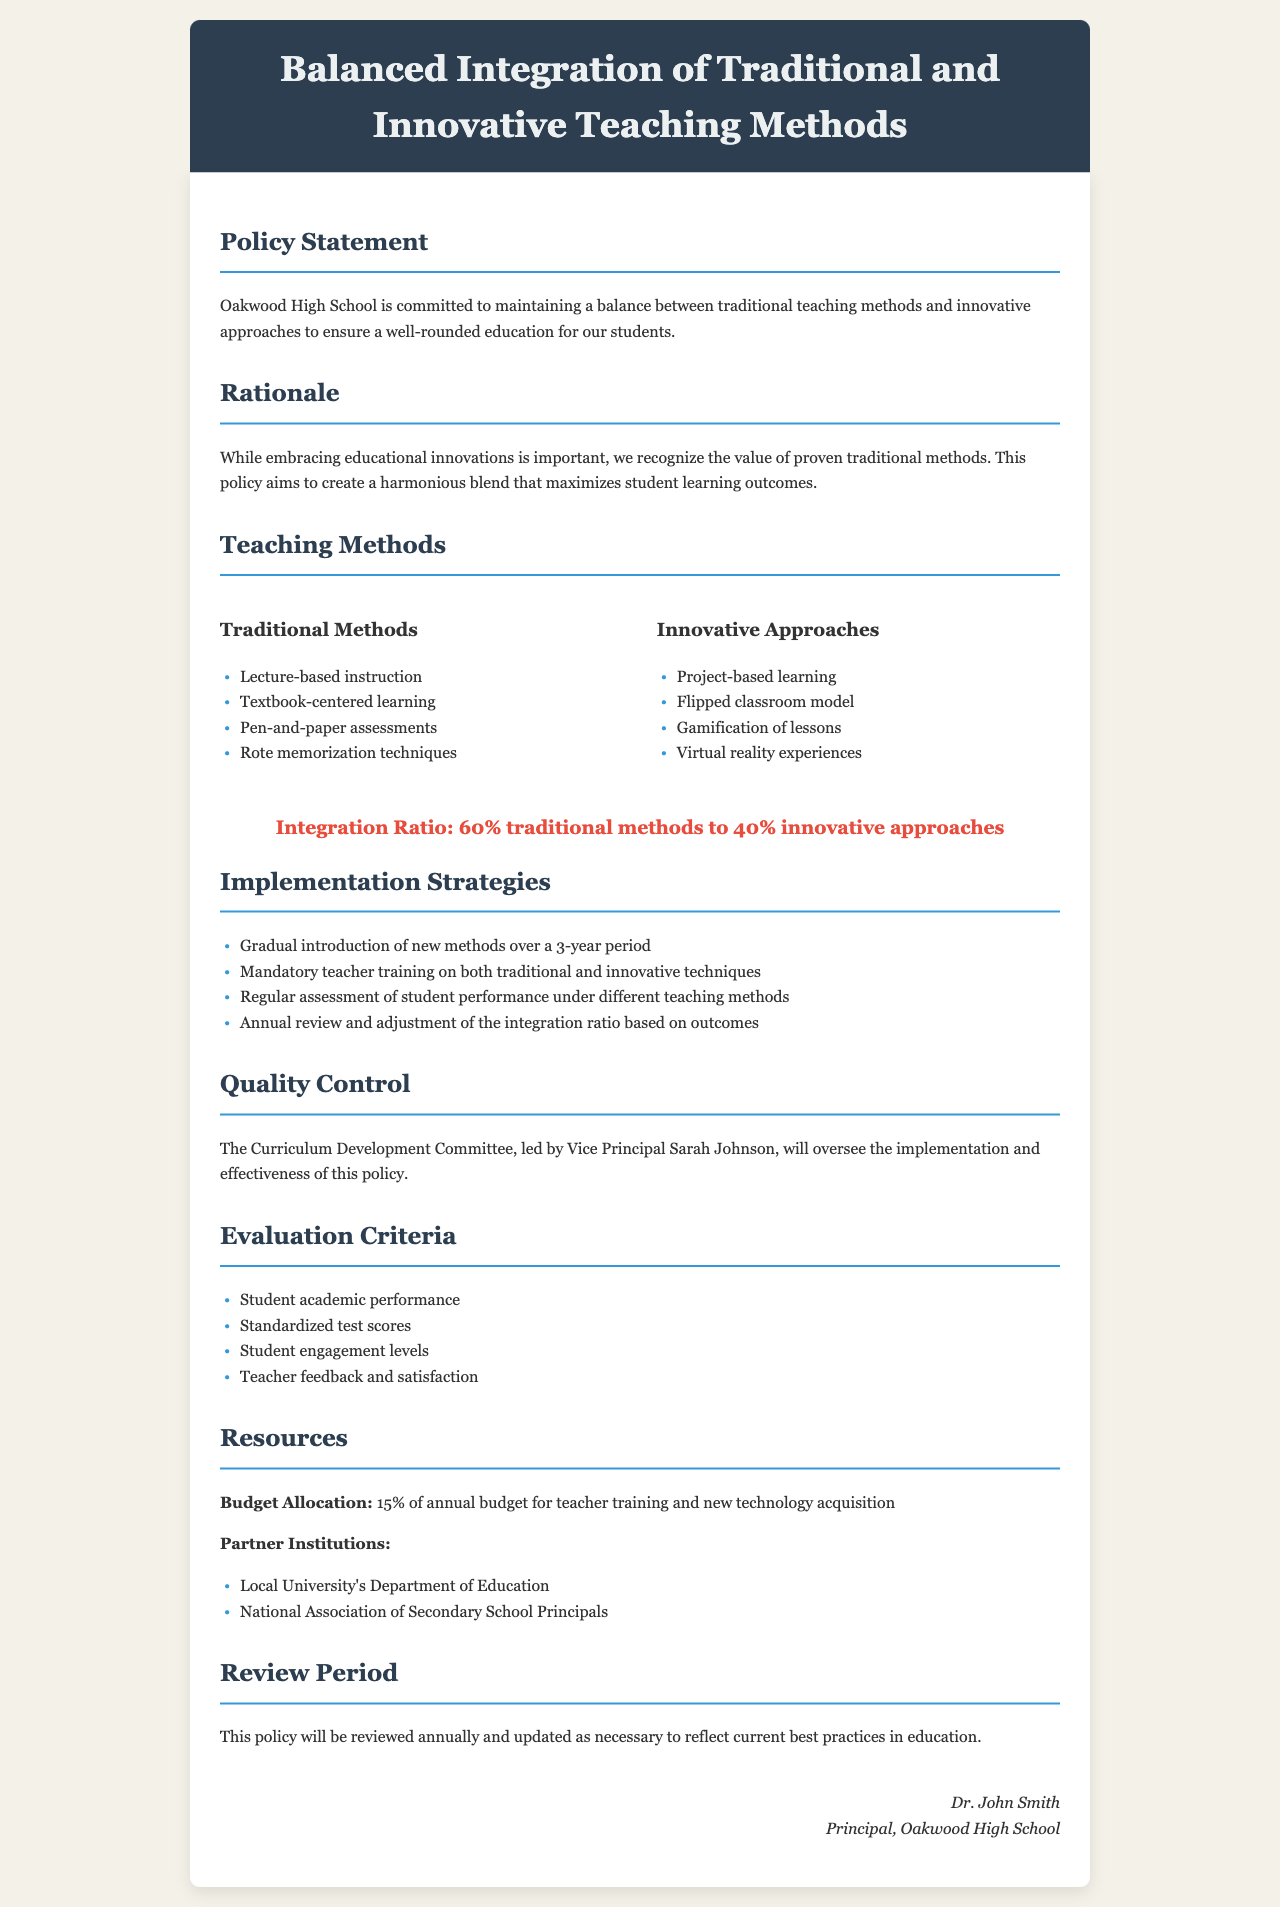What is the integration ratio of traditional methods to innovative approaches? The document specifies that the integration ratio is 60% traditional methods to 40% innovative approaches.
Answer: 60% traditional, 40% innovative Who leads the Curriculum Development Committee? The document mentions that Vice Principal Sarah Johnson leads the Curriculum Development Committee.
Answer: Sarah Johnson What is the budget allocation for teacher training and new technology acquisition? The policy states that 15% of the annual budget is allocated for teacher training and new technology acquisition.
Answer: 15% How often will this policy be reviewed? The document outlines that the policy will be reviewed annually and updated as necessary.
Answer: Annually What is one method listed under traditional teaching methods? The document lists "Lecture-based instruction" as one of the traditional methods.
Answer: Lecture-based instruction What is one example of an innovative approach mentioned in the document? The document includes "Project-based learning" as an example of an innovative approach.
Answer: Project-based learning How long is the gradual introduction of new methods planned to take? The document specifies that the gradual introduction of new methods is planned over a 3-year period.
Answer: 3 years What are the evaluation criteria mentioned for the policy? The document lists criteria such as student academic performance and standardized test scores for evaluation.
Answer: Student academic performance, standardized test scores What is the purpose of this policy? The document states the purpose is to maintain a balance between traditional and innovative approaches for student learning.
Answer: To ensure a well-rounded education 